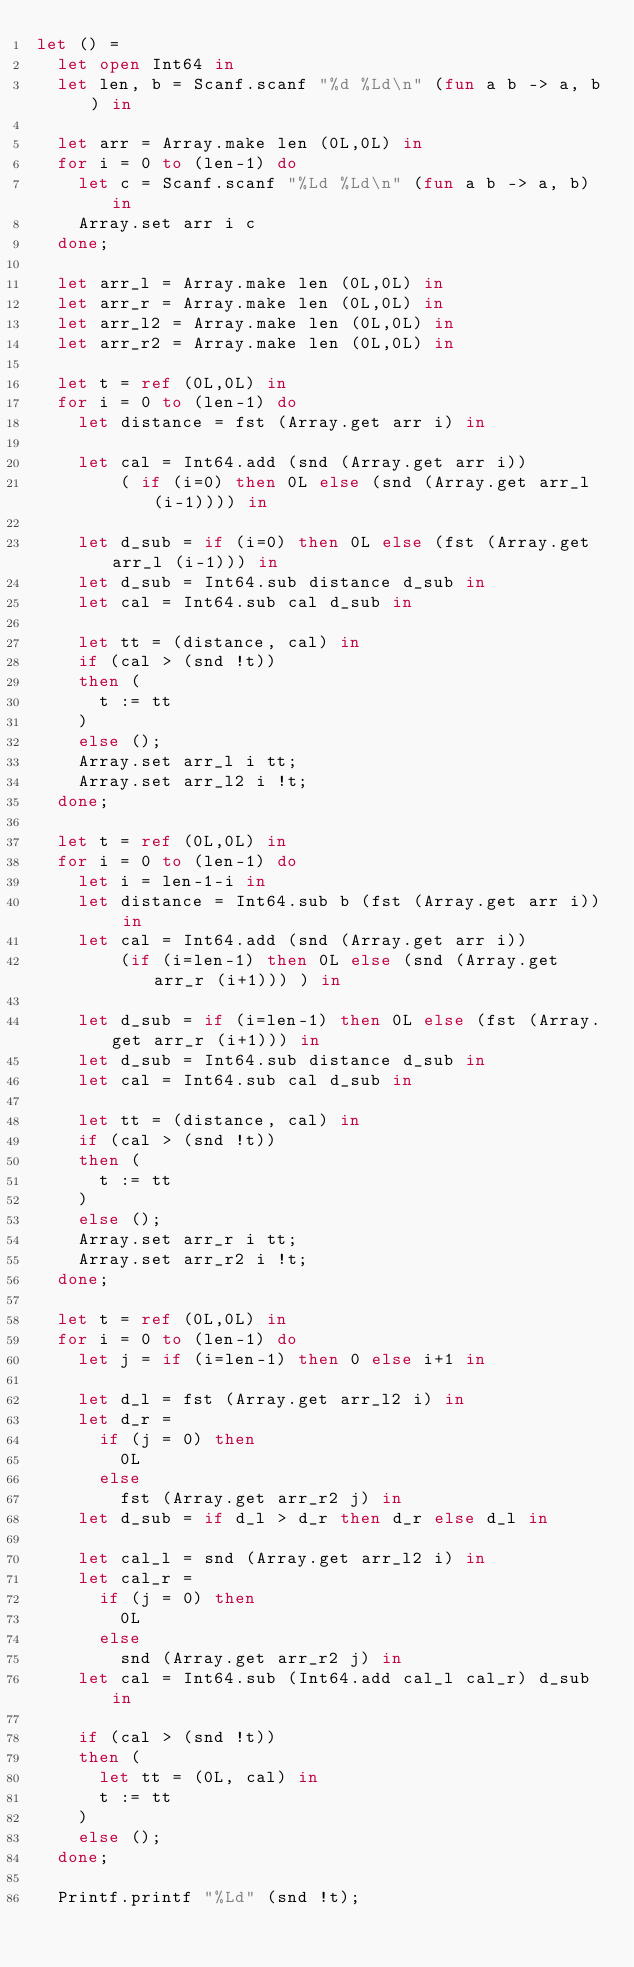Convert code to text. <code><loc_0><loc_0><loc_500><loc_500><_OCaml_>let () =
  let open Int64 in
  let len, b = Scanf.scanf "%d %Ld\n" (fun a b -> a, b) in

  let arr = Array.make len (0L,0L) in
  for i = 0 to (len-1) do
    let c = Scanf.scanf "%Ld %Ld\n" (fun a b -> a, b) in
    Array.set arr i c
  done;

  let arr_l = Array.make len (0L,0L) in
  let arr_r = Array.make len (0L,0L) in
  let arr_l2 = Array.make len (0L,0L) in
  let arr_r2 = Array.make len (0L,0L) in

  let t = ref (0L,0L) in
  for i = 0 to (len-1) do
    let distance = fst (Array.get arr i) in

    let cal = Int64.add (snd (Array.get arr i)) 
        ( if (i=0) then 0L else (snd (Array.get arr_l (i-1)))) in

    let d_sub = if (i=0) then 0L else (fst (Array.get arr_l (i-1))) in
    let d_sub = Int64.sub distance d_sub in
    let cal = Int64.sub cal d_sub in

    let tt = (distance, cal) in
    if (cal > (snd !t))
    then (
      t := tt
    )
    else ();
    Array.set arr_l i tt;
    Array.set arr_l2 i !t;
  done;

  let t = ref (0L,0L) in
  for i = 0 to (len-1) do
    let i = len-1-i in
    let distance = Int64.sub b (fst (Array.get arr i)) in
    let cal = Int64.add (snd (Array.get arr i))
        (if (i=len-1) then 0L else (snd (Array.get arr_r (i+1))) ) in

    let d_sub = if (i=len-1) then 0L else (fst (Array.get arr_r (i+1))) in
    let d_sub = Int64.sub distance d_sub in
    let cal = Int64.sub cal d_sub in

    let tt = (distance, cal) in
    if (cal > (snd !t))
    then (
      t := tt
    )
    else ();
    Array.set arr_r i tt;
    Array.set arr_r2 i !t;
  done;

  let t = ref (0L,0L) in
  for i = 0 to (len-1) do
    let j = if (i=len-1) then 0 else i+1 in

    let d_l = fst (Array.get arr_l2 i) in
    let d_r = 
      if (j = 0) then
        0L
      else
        fst (Array.get arr_r2 j) in
    let d_sub = if d_l > d_r then d_r else d_l in

    let cal_l = snd (Array.get arr_l2 i) in
    let cal_r = 
      if (j = 0) then
        0L
      else
        snd (Array.get arr_r2 j) in
    let cal = Int64.sub (Int64.add cal_l cal_r) d_sub in

    if (cal > (snd !t))
    then (
      let tt = (0L, cal) in
      t := tt
    )
    else ();
  done;

  Printf.printf "%Ld" (snd !t);

</code> 